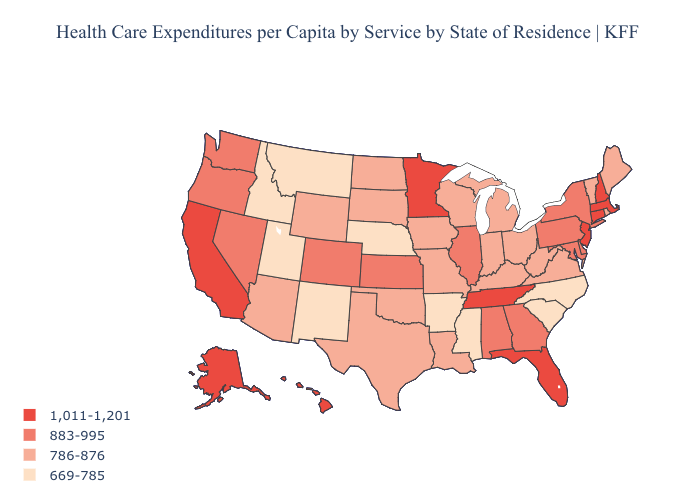Among the states that border Utah , does Nevada have the highest value?
Be succinct. Yes. Does the map have missing data?
Answer briefly. No. Does Maine have the lowest value in the Northeast?
Keep it brief. Yes. What is the value of Maine?
Concise answer only. 786-876. What is the highest value in the USA?
Answer briefly. 1,011-1,201. Which states have the highest value in the USA?
Write a very short answer. Alaska, California, Connecticut, Florida, Hawaii, Massachusetts, Minnesota, New Hampshire, New Jersey, Tennessee. Which states have the lowest value in the USA?
Write a very short answer. Arkansas, Idaho, Mississippi, Montana, Nebraska, New Mexico, North Carolina, South Carolina, Utah. Does South Carolina have the lowest value in the USA?
Be succinct. Yes. Does Florida have the highest value in the South?
Quick response, please. Yes. Which states have the lowest value in the West?
Keep it brief. Idaho, Montana, New Mexico, Utah. Which states hav the highest value in the West?
Write a very short answer. Alaska, California, Hawaii. Among the states that border South Carolina , which have the highest value?
Be succinct. Georgia. How many symbols are there in the legend?
Be succinct. 4. Name the states that have a value in the range 786-876?
Keep it brief. Arizona, Indiana, Iowa, Kentucky, Louisiana, Maine, Michigan, Missouri, North Dakota, Ohio, Oklahoma, Rhode Island, South Dakota, Texas, Vermont, Virginia, West Virginia, Wisconsin, Wyoming. Name the states that have a value in the range 883-995?
Quick response, please. Alabama, Colorado, Delaware, Georgia, Illinois, Kansas, Maryland, Nevada, New York, Oregon, Pennsylvania, Washington. 